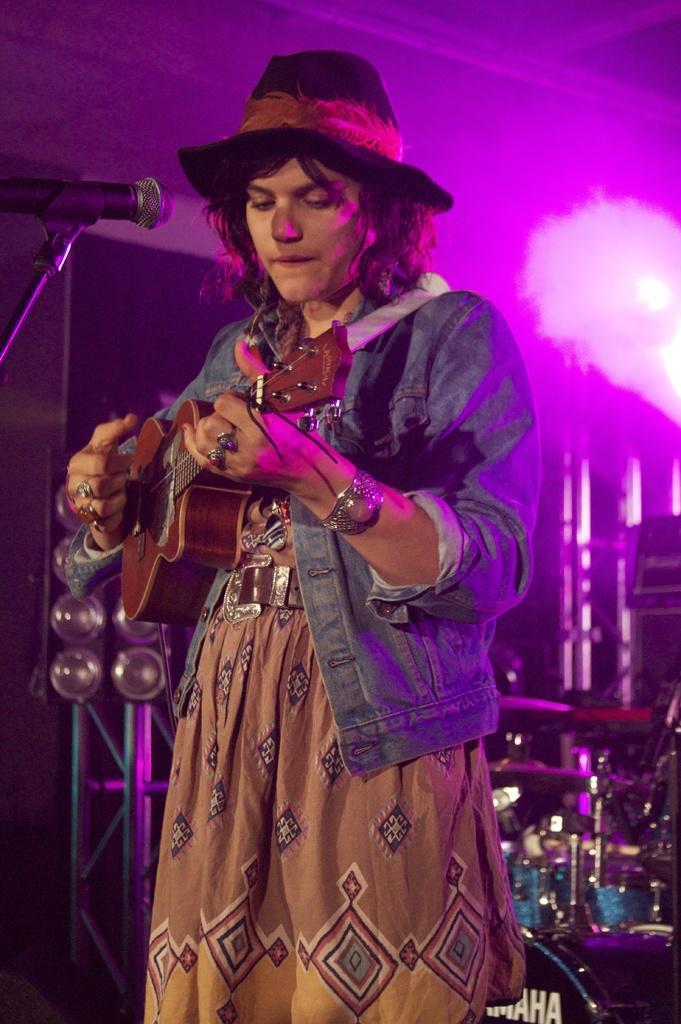Can you describe this image briefly? This is the woman standing and playing guitar. She wore a hat,jacket. This is the mic attached to the mike stand. This looks like drums,and the background is pinkish in color. I think these are the lights. 